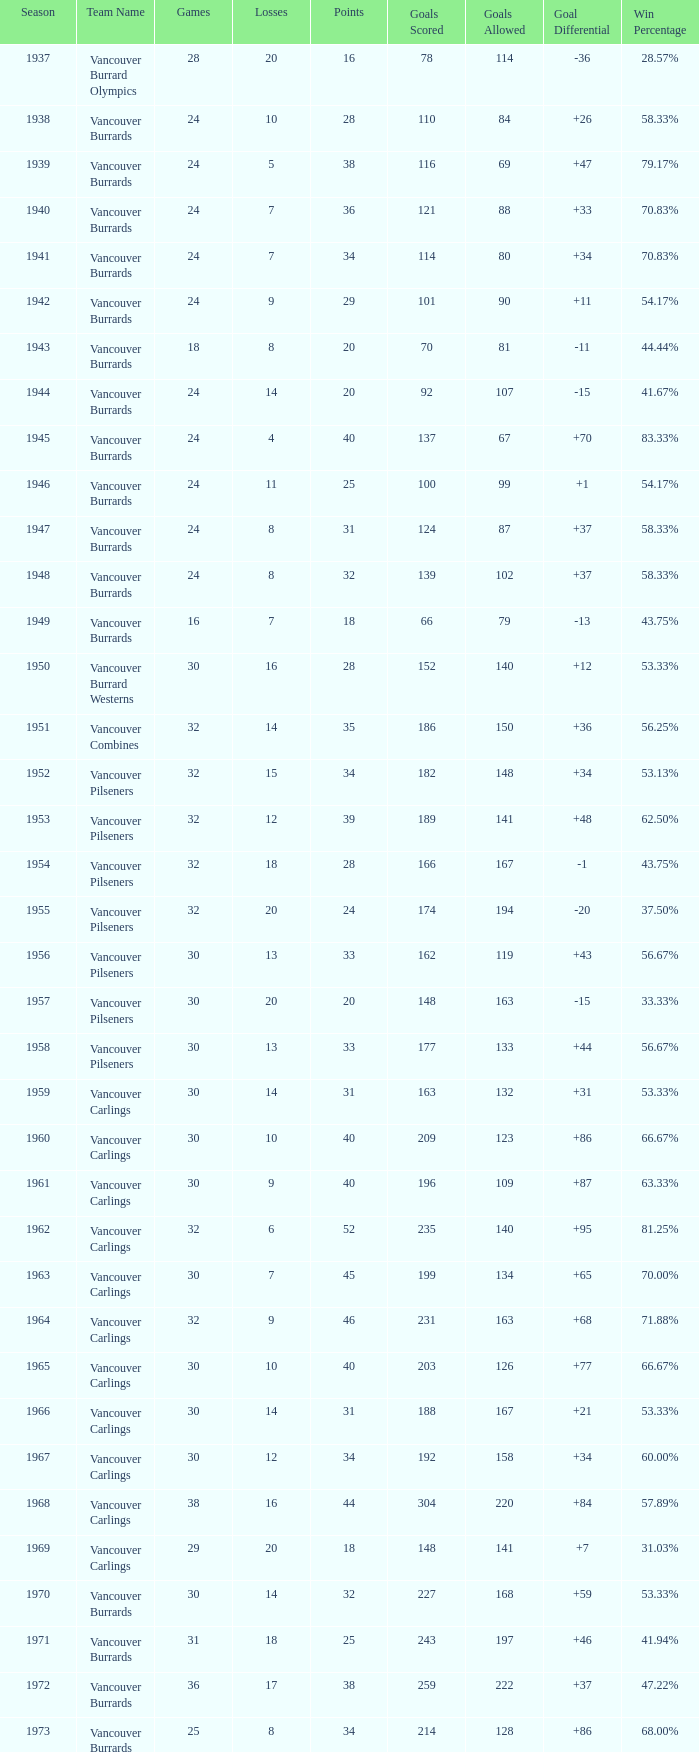What's the total number of points when the vancouver carlings have fewer than 12 losses and more than 32 games? 0.0. 